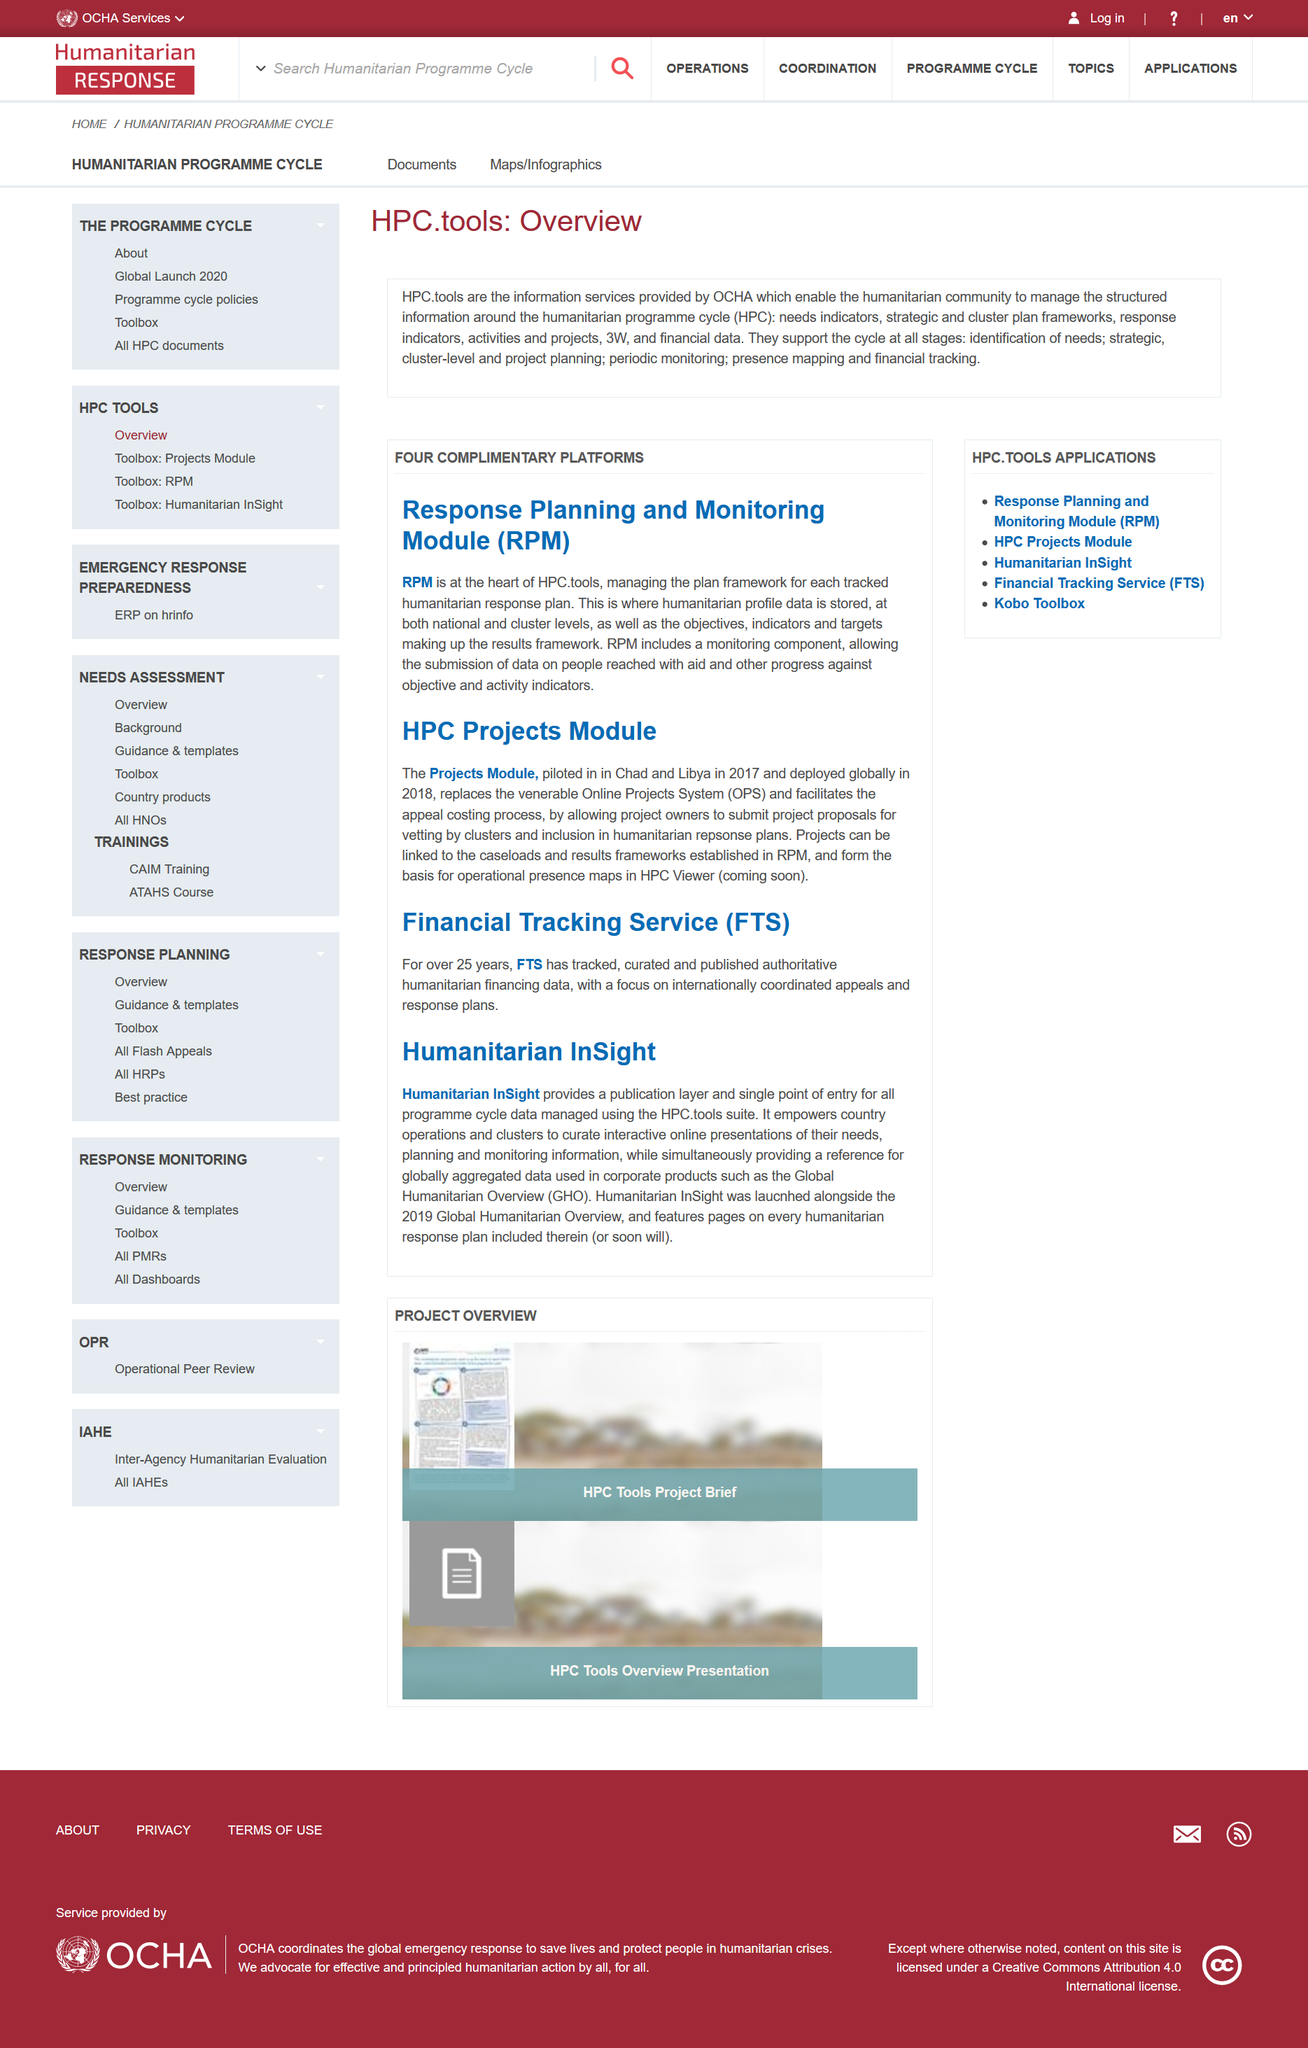Point out several critical features in this image. The HPC tools applications are RPM, HPC Projects Module, Humanitarian InSight, FTS, and Kobo Toolbox. There are a total of four complimentary platforms. The HPC suite contains three products: the Projects Module, the Financial Tracking Service, and the Humanitarian InSight. These products have been described as providing a range of functionalities and capabilities to support humanitarian efforts. The HPC Projects Module replaced the Online Projects System. RPM is at the heart of High Performance Computing, and it is what makes HPC possible. 